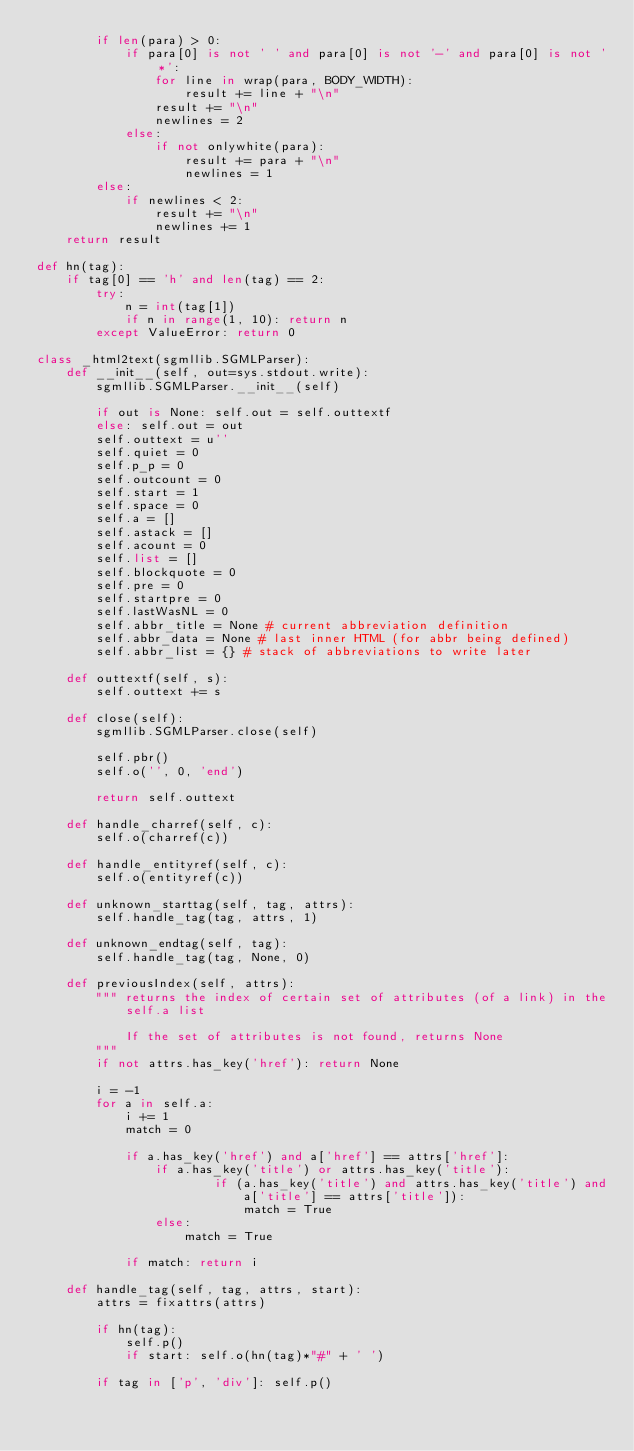Convert code to text. <code><loc_0><loc_0><loc_500><loc_500><_Python_>        if len(para) > 0:
            if para[0] is not ' ' and para[0] is not '-' and para[0] is not '*':
                for line in wrap(para, BODY_WIDTH):
                    result += line + "\n"
                result += "\n"
                newlines = 2
            else:
                if not onlywhite(para):
                    result += para + "\n"
                    newlines = 1
        else:
            if newlines < 2:
                result += "\n"
                newlines += 1
    return result

def hn(tag):
    if tag[0] == 'h' and len(tag) == 2:
        try:
            n = int(tag[1])
            if n in range(1, 10): return n
        except ValueError: return 0

class _html2text(sgmllib.SGMLParser):
    def __init__(self, out=sys.stdout.write):
        sgmllib.SGMLParser.__init__(self)
        
        if out is None: self.out = self.outtextf
        else: self.out = out
        self.outtext = u''
        self.quiet = 0
        self.p_p = 0
        self.outcount = 0
        self.start = 1
        self.space = 0
        self.a = []
        self.astack = []
        self.acount = 0
        self.list = []
        self.blockquote = 0
        self.pre = 0
        self.startpre = 0
        self.lastWasNL = 0
        self.abbr_title = None # current abbreviation definition
        self.abbr_data = None # last inner HTML (for abbr being defined)
        self.abbr_list = {} # stack of abbreviations to write later
    
    def outtextf(self, s): 
        self.outtext += s
    
    def close(self):
        sgmllib.SGMLParser.close(self)
        
        self.pbr()
        self.o('', 0, 'end')
        
        return self.outtext
        
    def handle_charref(self, c):
        self.o(charref(c))

    def handle_entityref(self, c):
        self.o(entityref(c))
            
    def unknown_starttag(self, tag, attrs):
        self.handle_tag(tag, attrs, 1)
    
    def unknown_endtag(self, tag):
        self.handle_tag(tag, None, 0)
        
    def previousIndex(self, attrs):
        """ returns the index of certain set of attributes (of a link) in the
            self.a list
 
            If the set of attributes is not found, returns None
        """
        if not attrs.has_key('href'): return None
        
        i = -1
        for a in self.a:
            i += 1
            match = 0
            
            if a.has_key('href') and a['href'] == attrs['href']:
                if a.has_key('title') or attrs.has_key('title'):
                        if (a.has_key('title') and attrs.has_key('title') and
                            a['title'] == attrs['title']):
                            match = True
                else:
                    match = True

            if match: return i

    def handle_tag(self, tag, attrs, start):
        attrs = fixattrs(attrs)
    
        if hn(tag):
            self.p()
            if start: self.o(hn(tag)*"#" + ' ')

        if tag in ['p', 'div']: self.p()
        </code> 